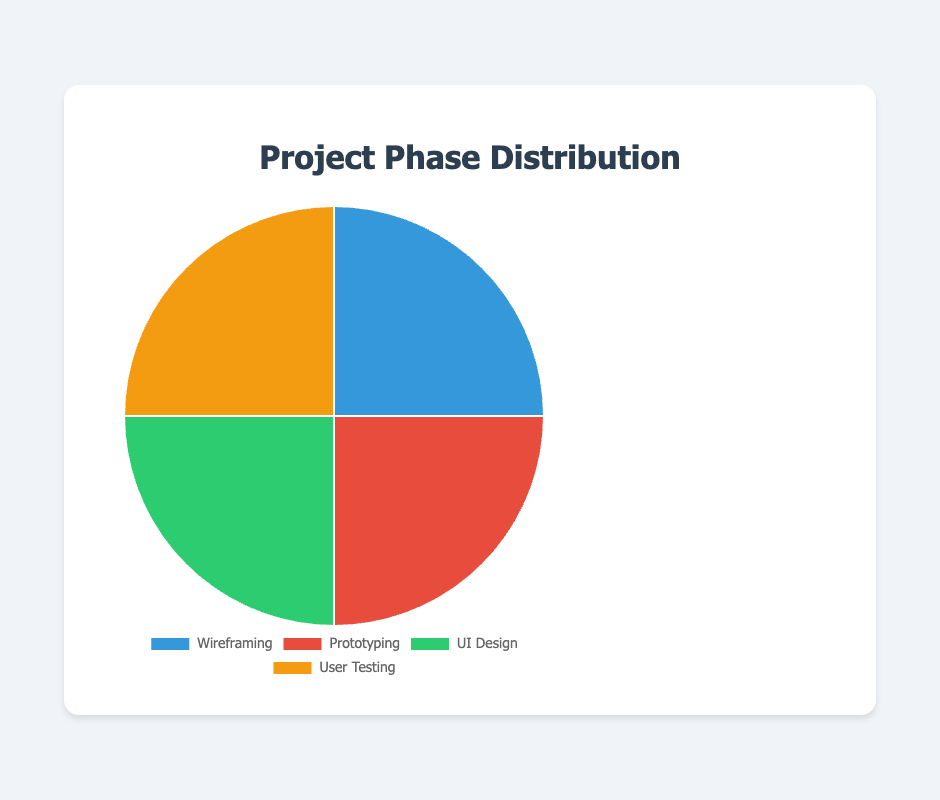Which project phase has the most tools used? By counting the number of tools used in each project phase (Wireframing: 4, Prototyping: 4, UI Design: 4, User Testing: 4), they all use the same number of tools.
Answer: All phases equally What is the difference between the number of tools used in Wireframing and Prototyping? Both Wireframing and Prototyping use 4 tools each, so the difference is 0.
Answer: 0 Which phase predominantly uses a single tool more than any other? User Testing predominantly uses UserTesting with 50%, higher than any other single tool's usage in other phases.
Answer: User Testing How many tools are used in total across all phases? Each phase uses 4 tools and there are 4 phases, so total tools used are 4 * 4 = 16.
Answer: 16 What percentage of tools used are for Prototyping? There are 16 tools in total used, and Prototyping uses 4, so the percentage is (4/16) * 100 = 25%.
Answer: 25% What is the combined percentage of tools used in Wireframing and UI Design phases? Each phase uses 4 tools out of 16 total, so the combined percentage is (4+4)/16 * 100 = 50%.
Answer: 50% Is the usage of tools in User Testing more than in Wireframing? Both phases use exactly 4 tools each, so their usage is equal.
Answer: No Which project phase uses the least number of tools? All project phases use the same number of tools, which is 4.
Answer: None What is the ratio of tools used in Prototyping to UI Design? Both Prototyping and UI Design use 4 tools each, so the ratio is 4:4 or 1:1.
Answer: 1:1 